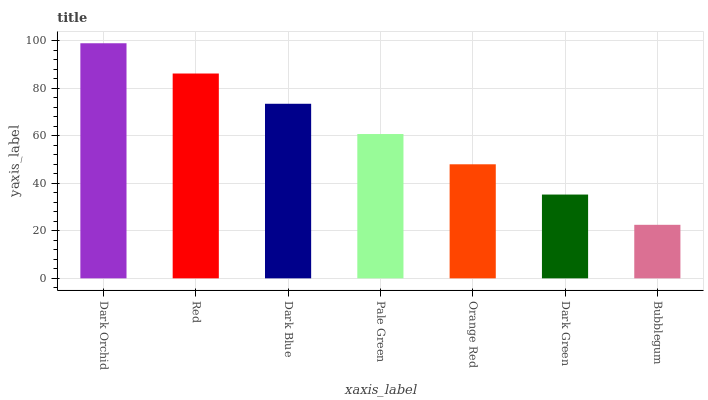Is Red the minimum?
Answer yes or no. No. Is Red the maximum?
Answer yes or no. No. Is Dark Orchid greater than Red?
Answer yes or no. Yes. Is Red less than Dark Orchid?
Answer yes or no. Yes. Is Red greater than Dark Orchid?
Answer yes or no. No. Is Dark Orchid less than Red?
Answer yes or no. No. Is Pale Green the high median?
Answer yes or no. Yes. Is Pale Green the low median?
Answer yes or no. Yes. Is Dark Blue the high median?
Answer yes or no. No. Is Dark Orchid the low median?
Answer yes or no. No. 